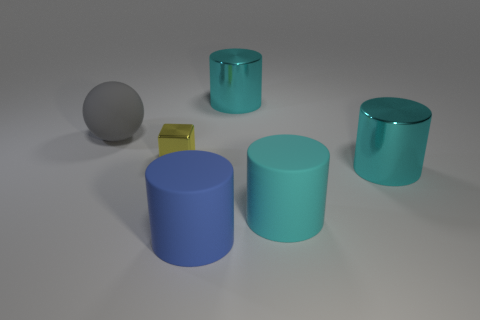Is the tiny yellow block made of the same material as the cylinder behind the big ball?
Provide a short and direct response. Yes. How many purple shiny cylinders are there?
Make the answer very short. 0. There is a yellow metal thing in front of the big ball; what is its size?
Your response must be concise. Small. What number of cyan rubber cylinders are the same size as the ball?
Ensure brevity in your answer.  1. What is the object that is behind the yellow shiny cube and left of the blue rubber cylinder made of?
Offer a terse response. Rubber. There is a yellow block that is behind the large rubber object to the right of the blue object that is in front of the small yellow shiny object; how big is it?
Make the answer very short. Small. Is the size of the blue cylinder the same as the shiny thing that is on the left side of the big blue thing?
Keep it short and to the point. No. There is a cyan metal thing that is in front of the big sphere; what shape is it?
Provide a short and direct response. Cylinder. Are there any large matte things right of the large shiny thing that is behind the metallic cylinder that is in front of the large matte sphere?
Make the answer very short. Yes. What number of balls are big matte things or tiny objects?
Provide a short and direct response. 1. 